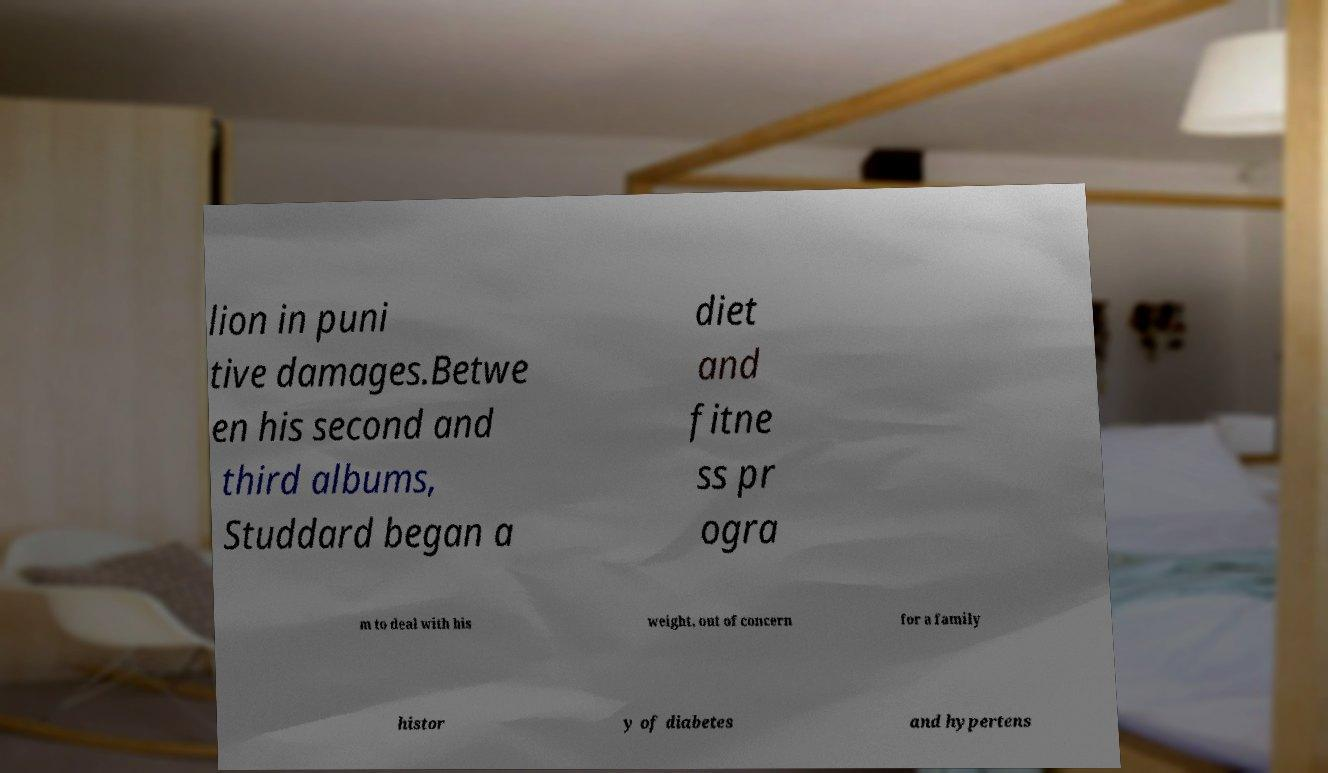Can you read and provide the text displayed in the image?This photo seems to have some interesting text. Can you extract and type it out for me? lion in puni tive damages.Betwe en his second and third albums, Studdard began a diet and fitne ss pr ogra m to deal with his weight, out of concern for a family histor y of diabetes and hypertens 